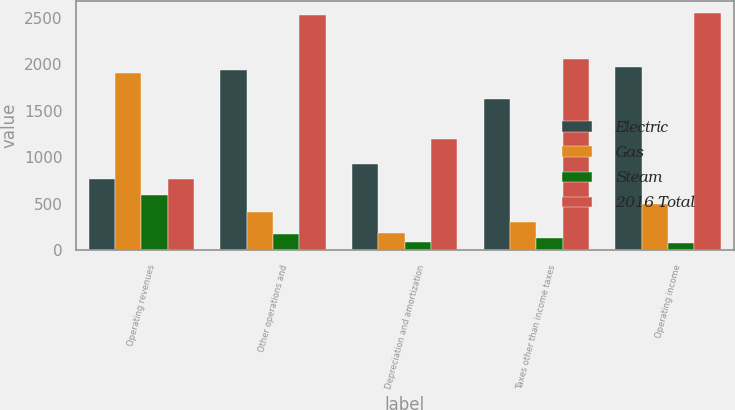Convert chart. <chart><loc_0><loc_0><loc_500><loc_500><stacked_bar_chart><ecel><fcel>Operating revenues<fcel>Other operations and<fcel>Depreciation and amortization<fcel>Taxes other than income taxes<fcel>Operating income<nl><fcel>Electric<fcel>760<fcel>1942<fcel>925<fcel>1625<fcel>1974<nl><fcel>Gas<fcel>1901<fcel>413<fcel>185<fcel>298<fcel>495<nl><fcel>Steam<fcel>595<fcel>171<fcel>85<fcel>134<fcel>80<nl><fcel>2016 Total<fcel>760<fcel>2526<fcel>1195<fcel>2057<fcel>2549<nl></chart> 